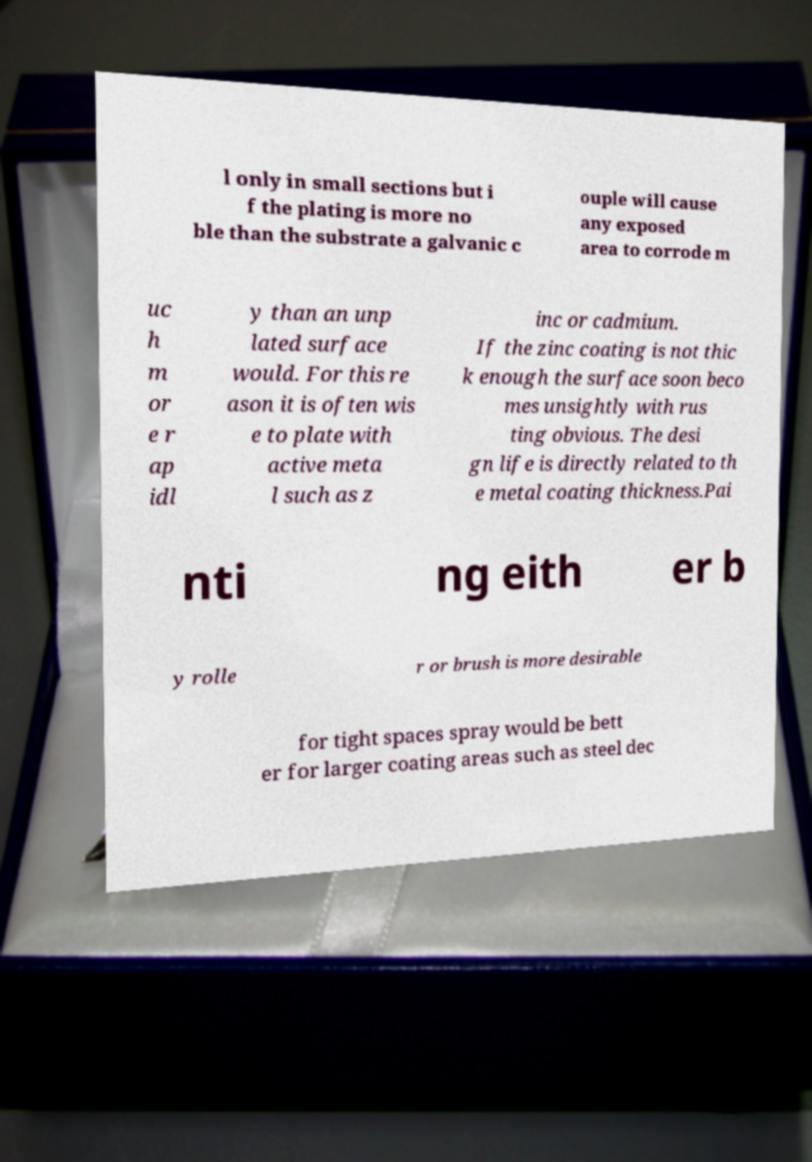There's text embedded in this image that I need extracted. Can you transcribe it verbatim? l only in small sections but i f the plating is more no ble than the substrate a galvanic c ouple will cause any exposed area to corrode m uc h m or e r ap idl y than an unp lated surface would. For this re ason it is often wis e to plate with active meta l such as z inc or cadmium. If the zinc coating is not thic k enough the surface soon beco mes unsightly with rus ting obvious. The desi gn life is directly related to th e metal coating thickness.Pai nti ng eith er b y rolle r or brush is more desirable for tight spaces spray would be bett er for larger coating areas such as steel dec 